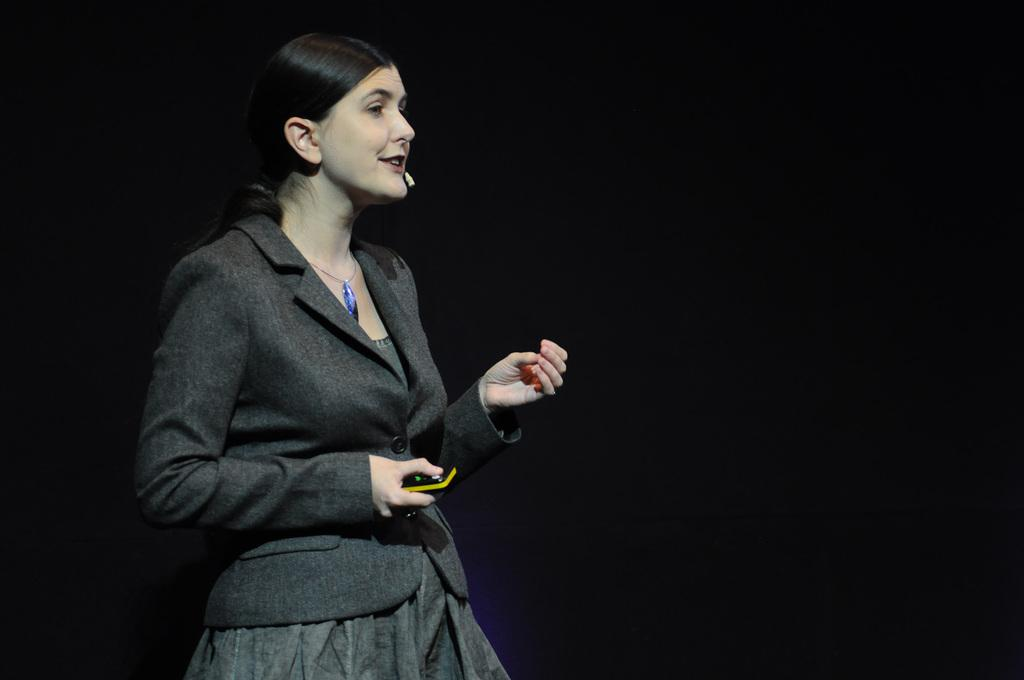Who is the main subject in the image? There is a woman in the image. What is the woman doing in the image? The woman is standing. What is the woman wearing in the image? The woman is wearing a black dress. What is the woman holding in the image? The woman is holding something. What can be seen in the background of the image? The background of the image is dark. What type of cracker is the woman eating in the image? There is no cracker present in the image, and the woman is not eating anything. 